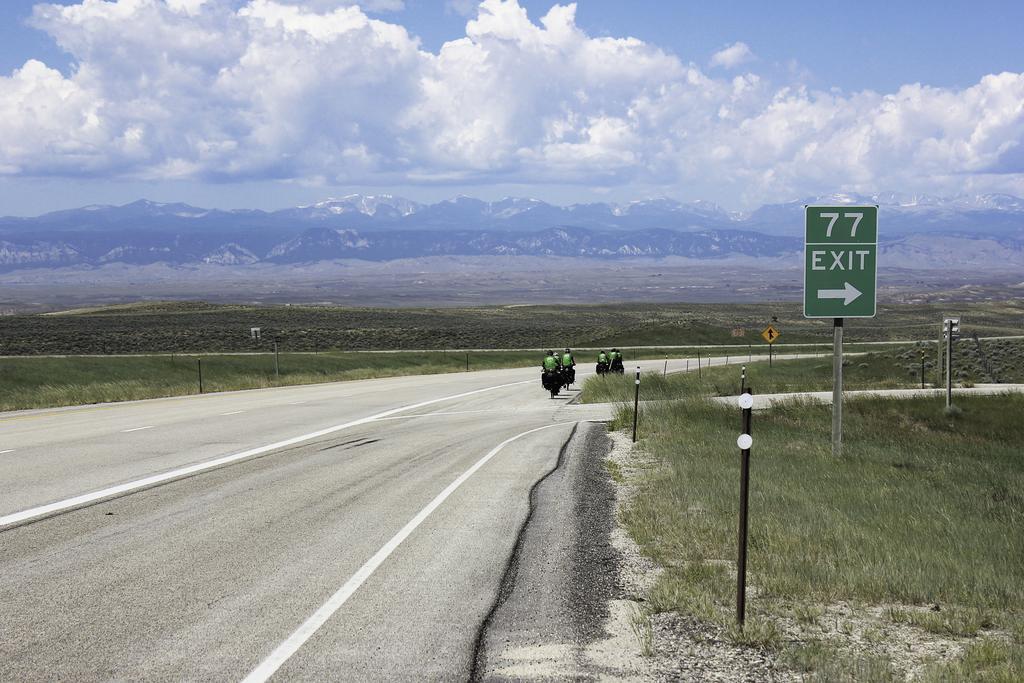Could you give a brief overview of what you see in this image? In this picture I can see few people riding bicycles and I can see grass on the ground, few plants and a board with some text. I can see hills in the black and a blue cloudy sky. 